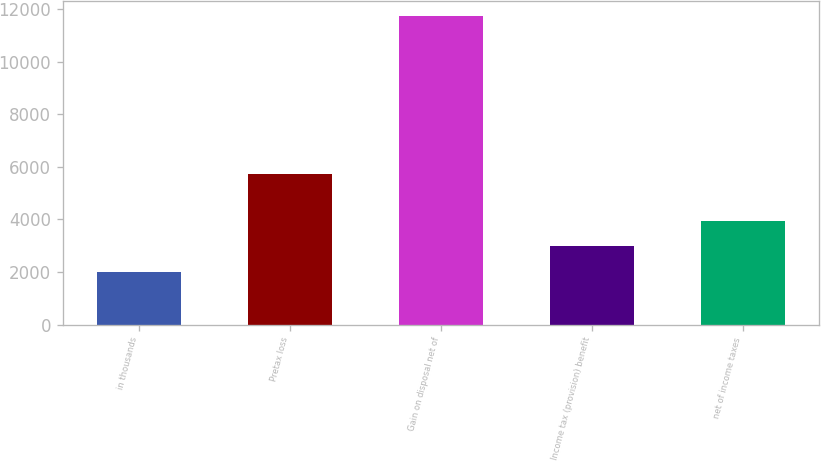<chart> <loc_0><loc_0><loc_500><loc_500><bar_chart><fcel>in thousands<fcel>Pretax loss<fcel>Gain on disposal net of<fcel>Income tax (provision) benefit<fcel>net of income taxes<nl><fcel>2013<fcel>5744<fcel>11728<fcel>2984.5<fcel>3956<nl></chart> 